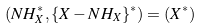<formula> <loc_0><loc_0><loc_500><loc_500>\left ( N H _ { X } ^ { * } , \{ X - N H _ { X } \} ^ { * } \right ) = \left ( X ^ { * } \right )</formula> 